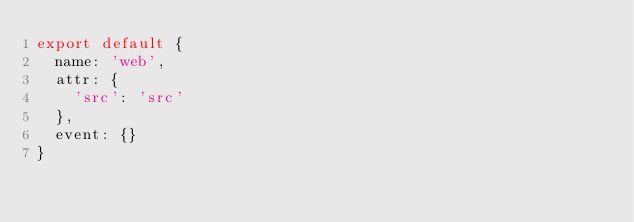Convert code to text. <code><loc_0><loc_0><loc_500><loc_500><_JavaScript_>export default {
  name: 'web',
  attr: {
    'src': 'src'
  },
  event: {}
}
</code> 